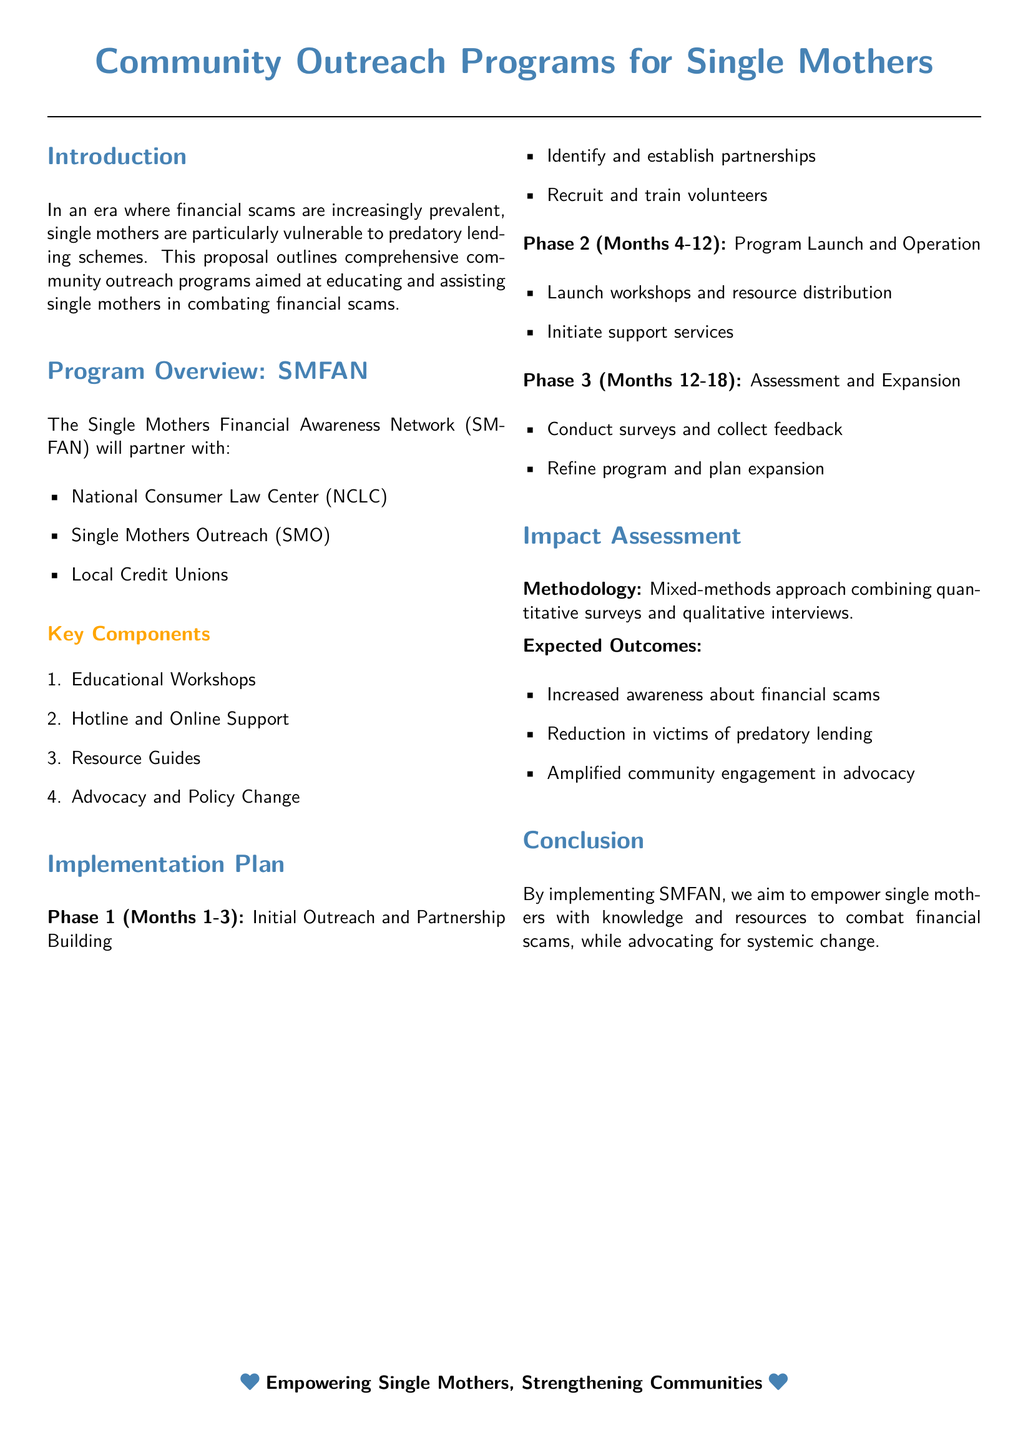What is the name of the network proposed? The proposal outlines the "Single Mothers Financial Awareness Network" (SMFAN).
Answer: Single Mothers Financial Awareness Network (SMFAN) Who are the partners involved in the program? The partners mentioned include the National Consumer Law Center (NCLC), Single Mothers Outreach (SMO), and Local Credit Unions.
Answer: National Consumer Law Center, Single Mothers Outreach, Local Credit Unions How many phases are there in the implementation plan? The implementation plan consists of three phases as outlined in the document.
Answer: Three What is the duration of Phase 1 in months? Phase 1 lasts from Month 1 to Month 3, totaling three months.
Answer: 3 What type of approach is used for the impact assessment? The methodology for the impact assessment is described as a mixed-methods approach.
Answer: Mixed-methods What is one expected outcome of the program? One of the expected outcomes mentioned is increased awareness about financial scams.
Answer: Increased awareness about financial scams What type of support will be provided according to the program overview? The program will include a hotline and online support for single mothers.
Answer: Hotline and Online Support What is the goal of the program as stated in the conclusion? The goal of the program is to empower single mothers with knowledge and resources to combat financial scams.
Answer: Empower single mothers to combat financial scams 